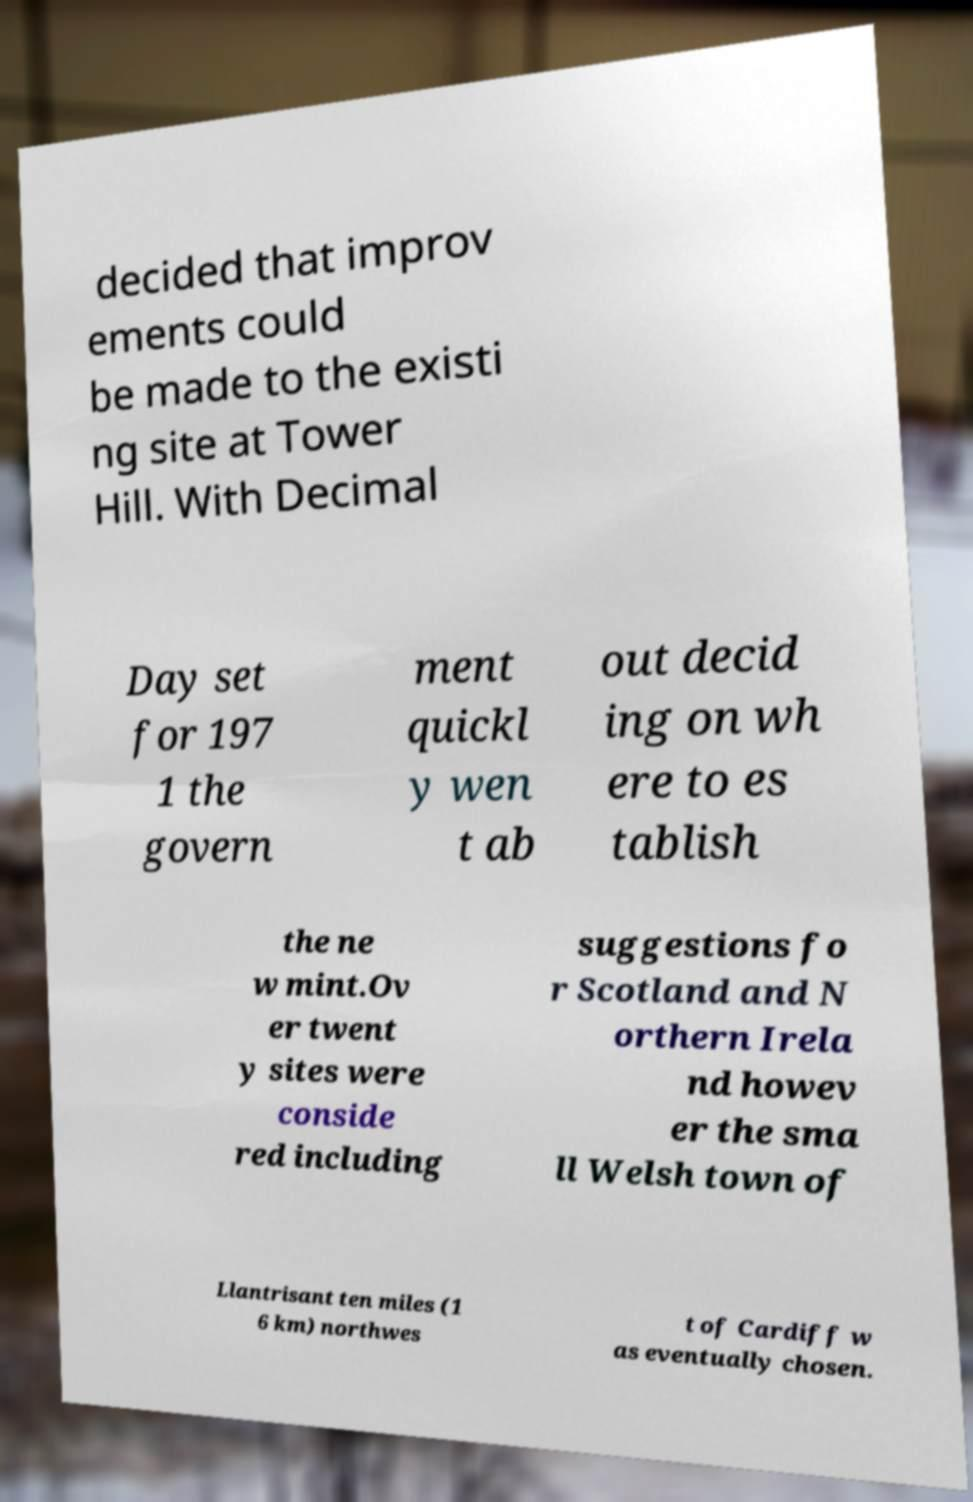Could you assist in decoding the text presented in this image and type it out clearly? decided that improv ements could be made to the existi ng site at Tower Hill. With Decimal Day set for 197 1 the govern ment quickl y wen t ab out decid ing on wh ere to es tablish the ne w mint.Ov er twent y sites were conside red including suggestions fo r Scotland and N orthern Irela nd howev er the sma ll Welsh town of Llantrisant ten miles (1 6 km) northwes t of Cardiff w as eventually chosen. 